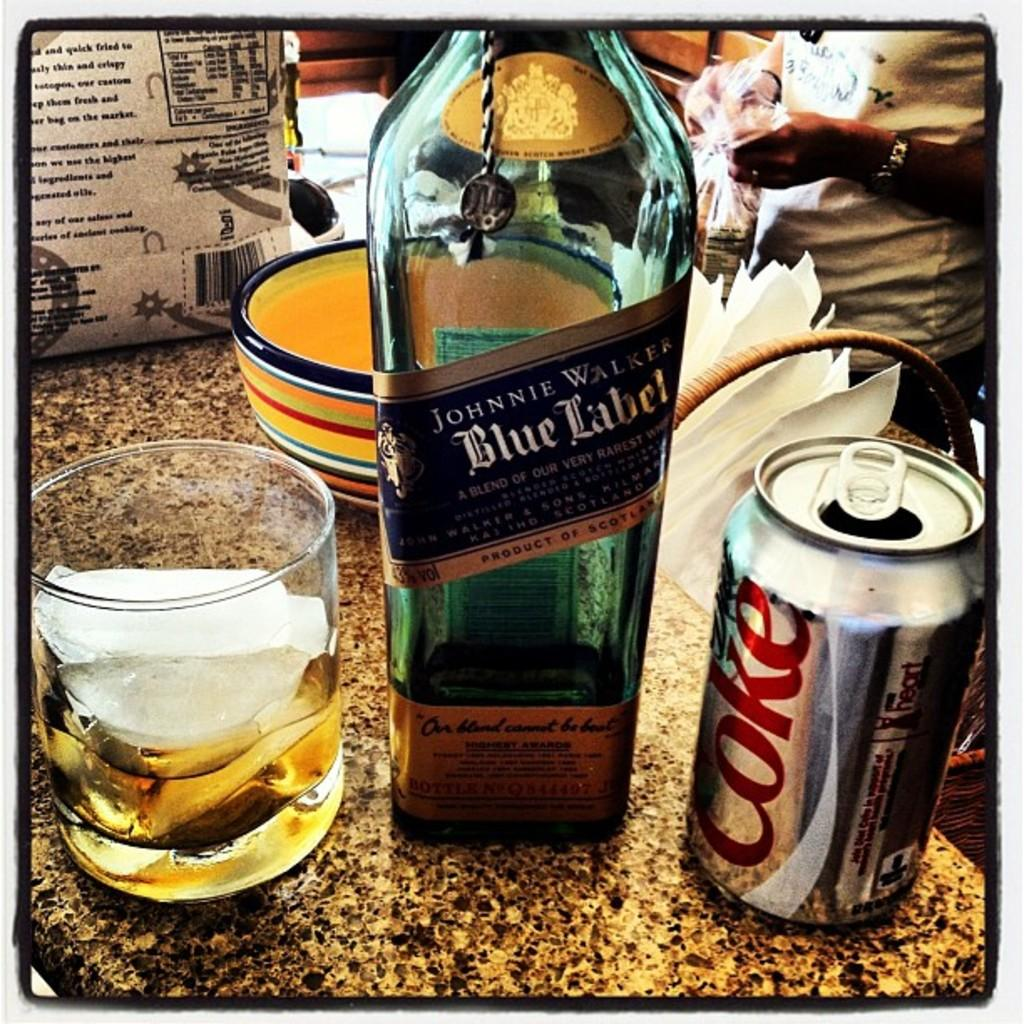What type of beverage container is in the image? There is a wine bottle in the image. What other container is present in the image? There is a tin in the image. What is the wine glass in the image being used for? The wine glass in the image has ice in it. What else can be seen on the table in the image? There are other objects on the table in the image. Can you describe the person in the background of the image? There is a person standing in the background of the image. What type of toothbrush is being used to clean the wine bottle in the image? There is no toothbrush present in the image, and the wine bottle is not being cleaned. 